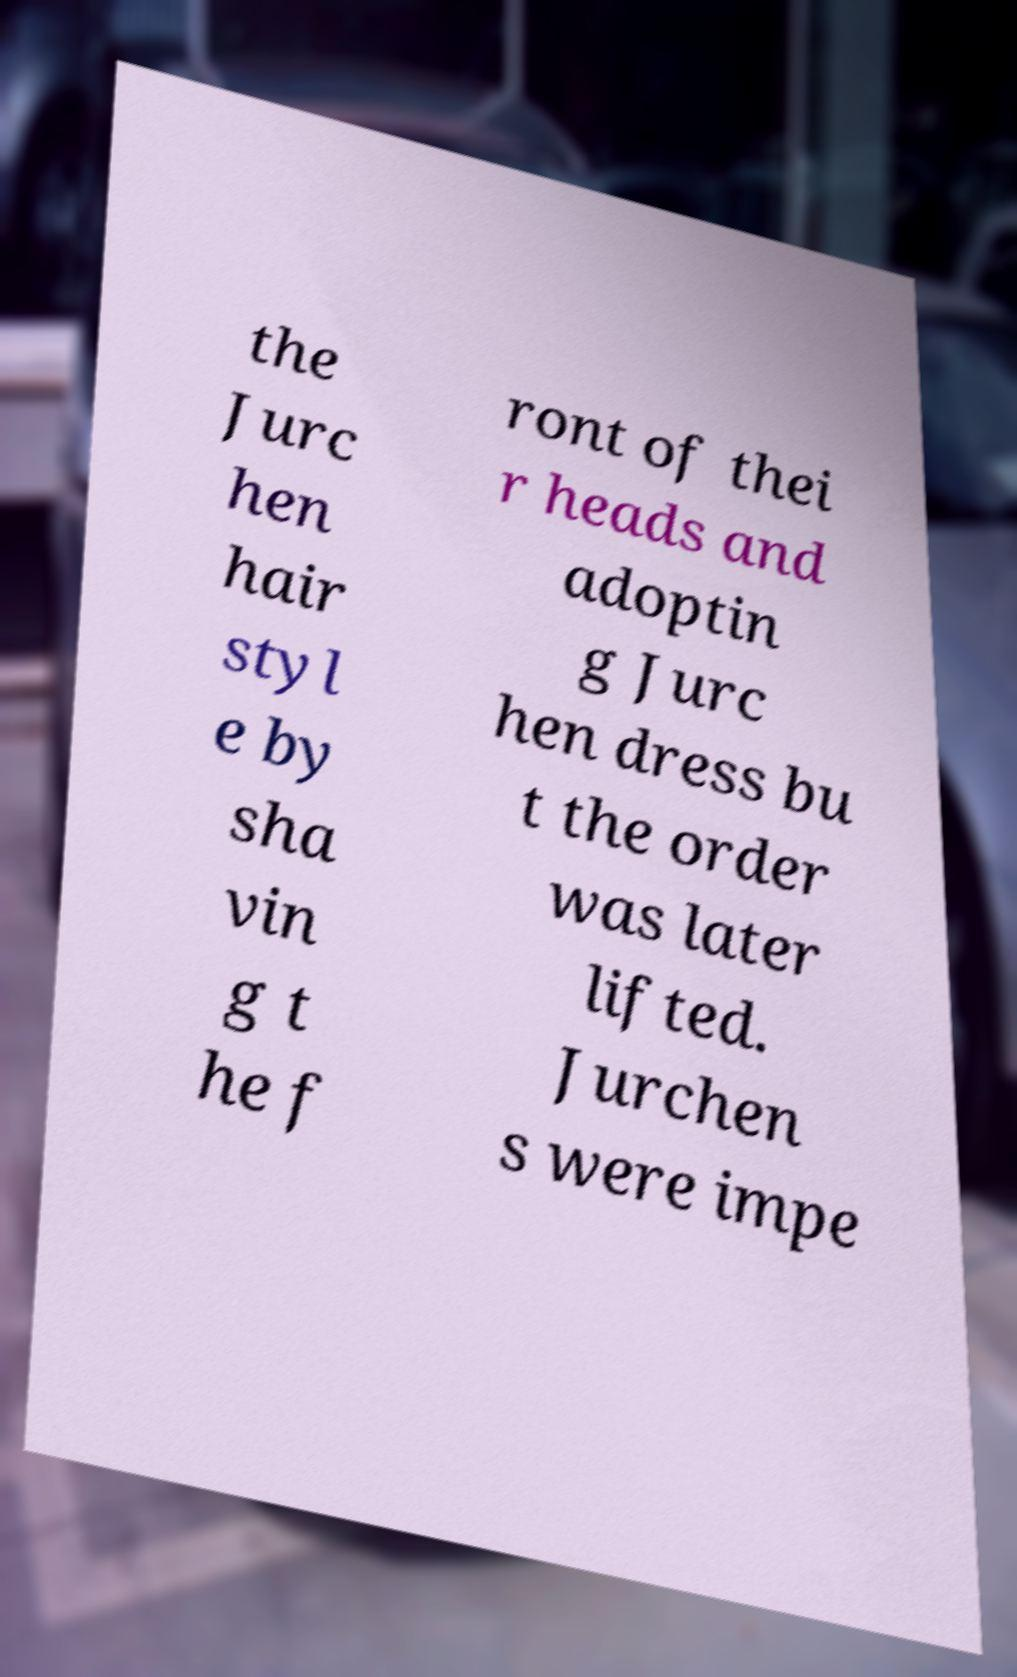Could you extract and type out the text from this image? the Jurc hen hair styl e by sha vin g t he f ront of thei r heads and adoptin g Jurc hen dress bu t the order was later lifted. Jurchen s were impe 